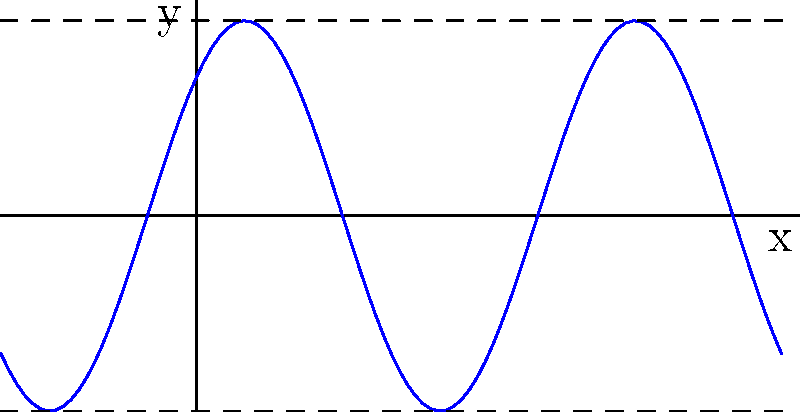Given the graph of the function $f(x) = A\sin(B(x-C)) + D$, determine the values of $A$, $B$, $C$, and $D$. Let's analyze the graph step by step:

1. Amplitude ($A$):
   The amplitude is half the distance between the maximum and minimum values.
   From the graph, we can see that the maximum is 2 and the minimum is -2.
   So, the amplitude is $(2 - (-2))/2 = 2$.
   Therefore, $A = 2$.

2. Period ($B$):
   The period of a sine function is given by $\frac{2\pi}{B}$.
   From the graph, we can see that one full cycle occurs over an interval of 4 units.
   So, $\frac{2\pi}{B} = 4$
   Solving for $B$: $B = \frac{2\pi}{4} = \frac{\pi}{2}$

3. Phase shift ($C$):
   The phase shift moves the graph horizontally. 
   For a sine function, the graph should start at the middle of its range (at $y=0$) when $x=0$.
   Here, the graph is shifted $\frac{1}{2}$ unit to the left.
   Therefore, $C = -\frac{1}{2}$.

4. Vertical shift ($D$):
   The vertical shift moves the graph up or down.
   The midline of the graph is at $y=0$, so there is no vertical shift.
   Therefore, $D = 0$.

Putting it all together, we have:
$f(x) = 2\sin(\frac{\pi}{2}(x+\frac{1}{2}))$

Note: This can also be written as $f(x) = 2\sin(\frac{\pi}{2}x + \frac{\pi}{4})$, which is equivalent.
Answer: $A=2$, $B=\frac{\pi}{2}$, $C=-\frac{1}{2}$, $D=0$ 